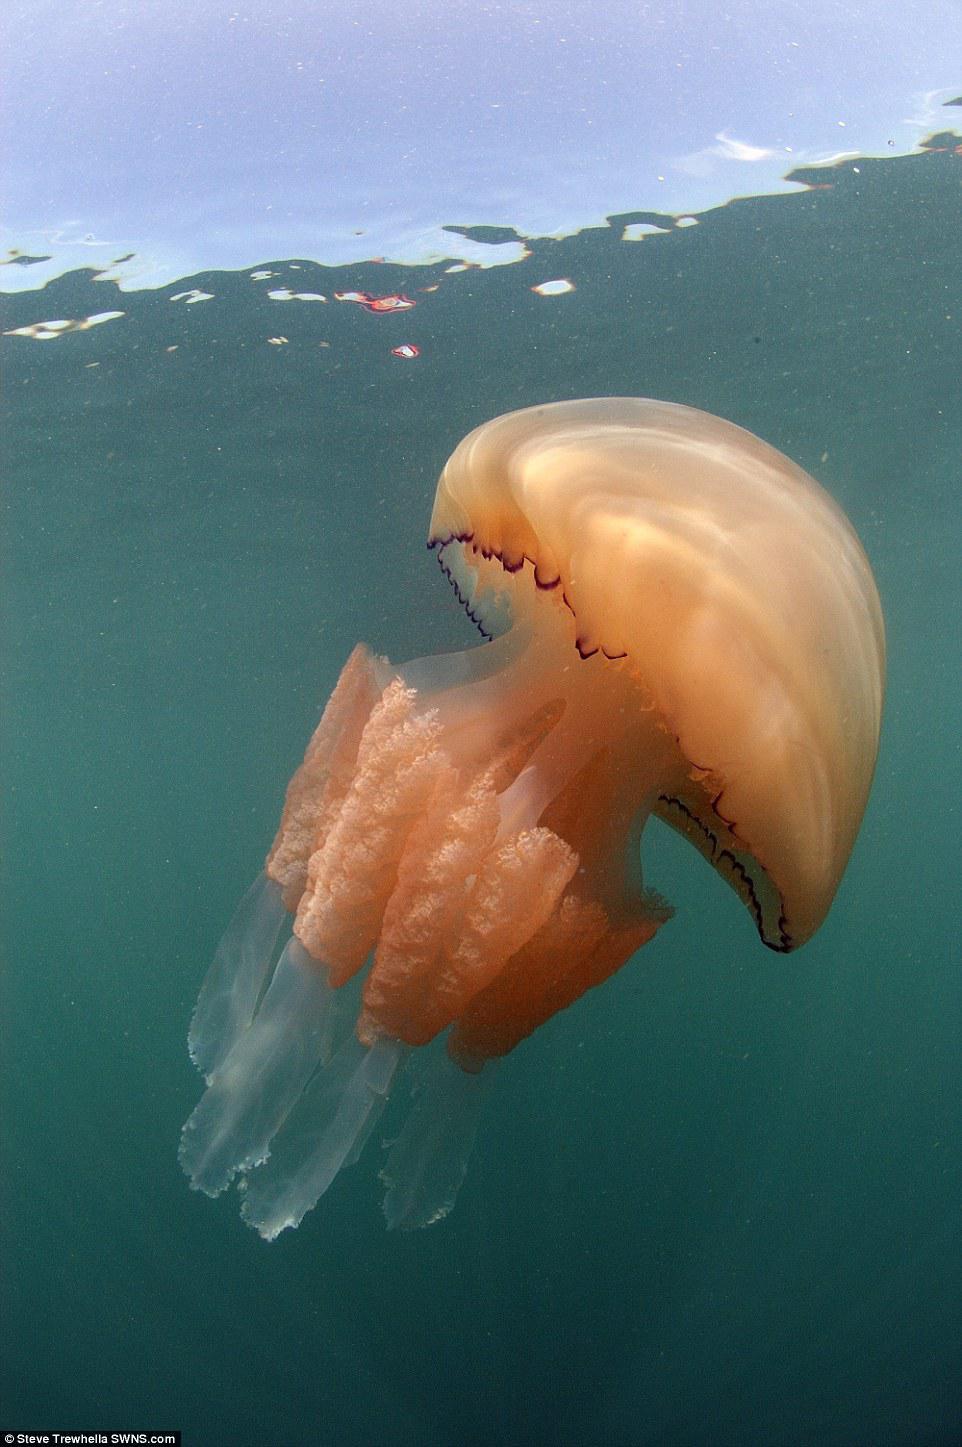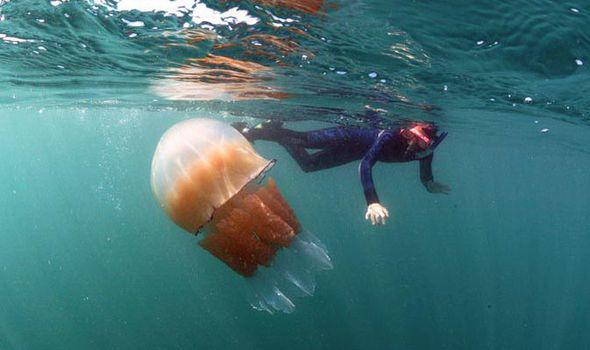The first image is the image on the left, the second image is the image on the right. Analyze the images presented: Is the assertion "There are two jellyfish, each one traveling the opposite direction as the other." valid? Answer yes or no. Yes. 